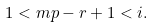Convert formula to latex. <formula><loc_0><loc_0><loc_500><loc_500>1 < m p - r + 1 < i .</formula> 